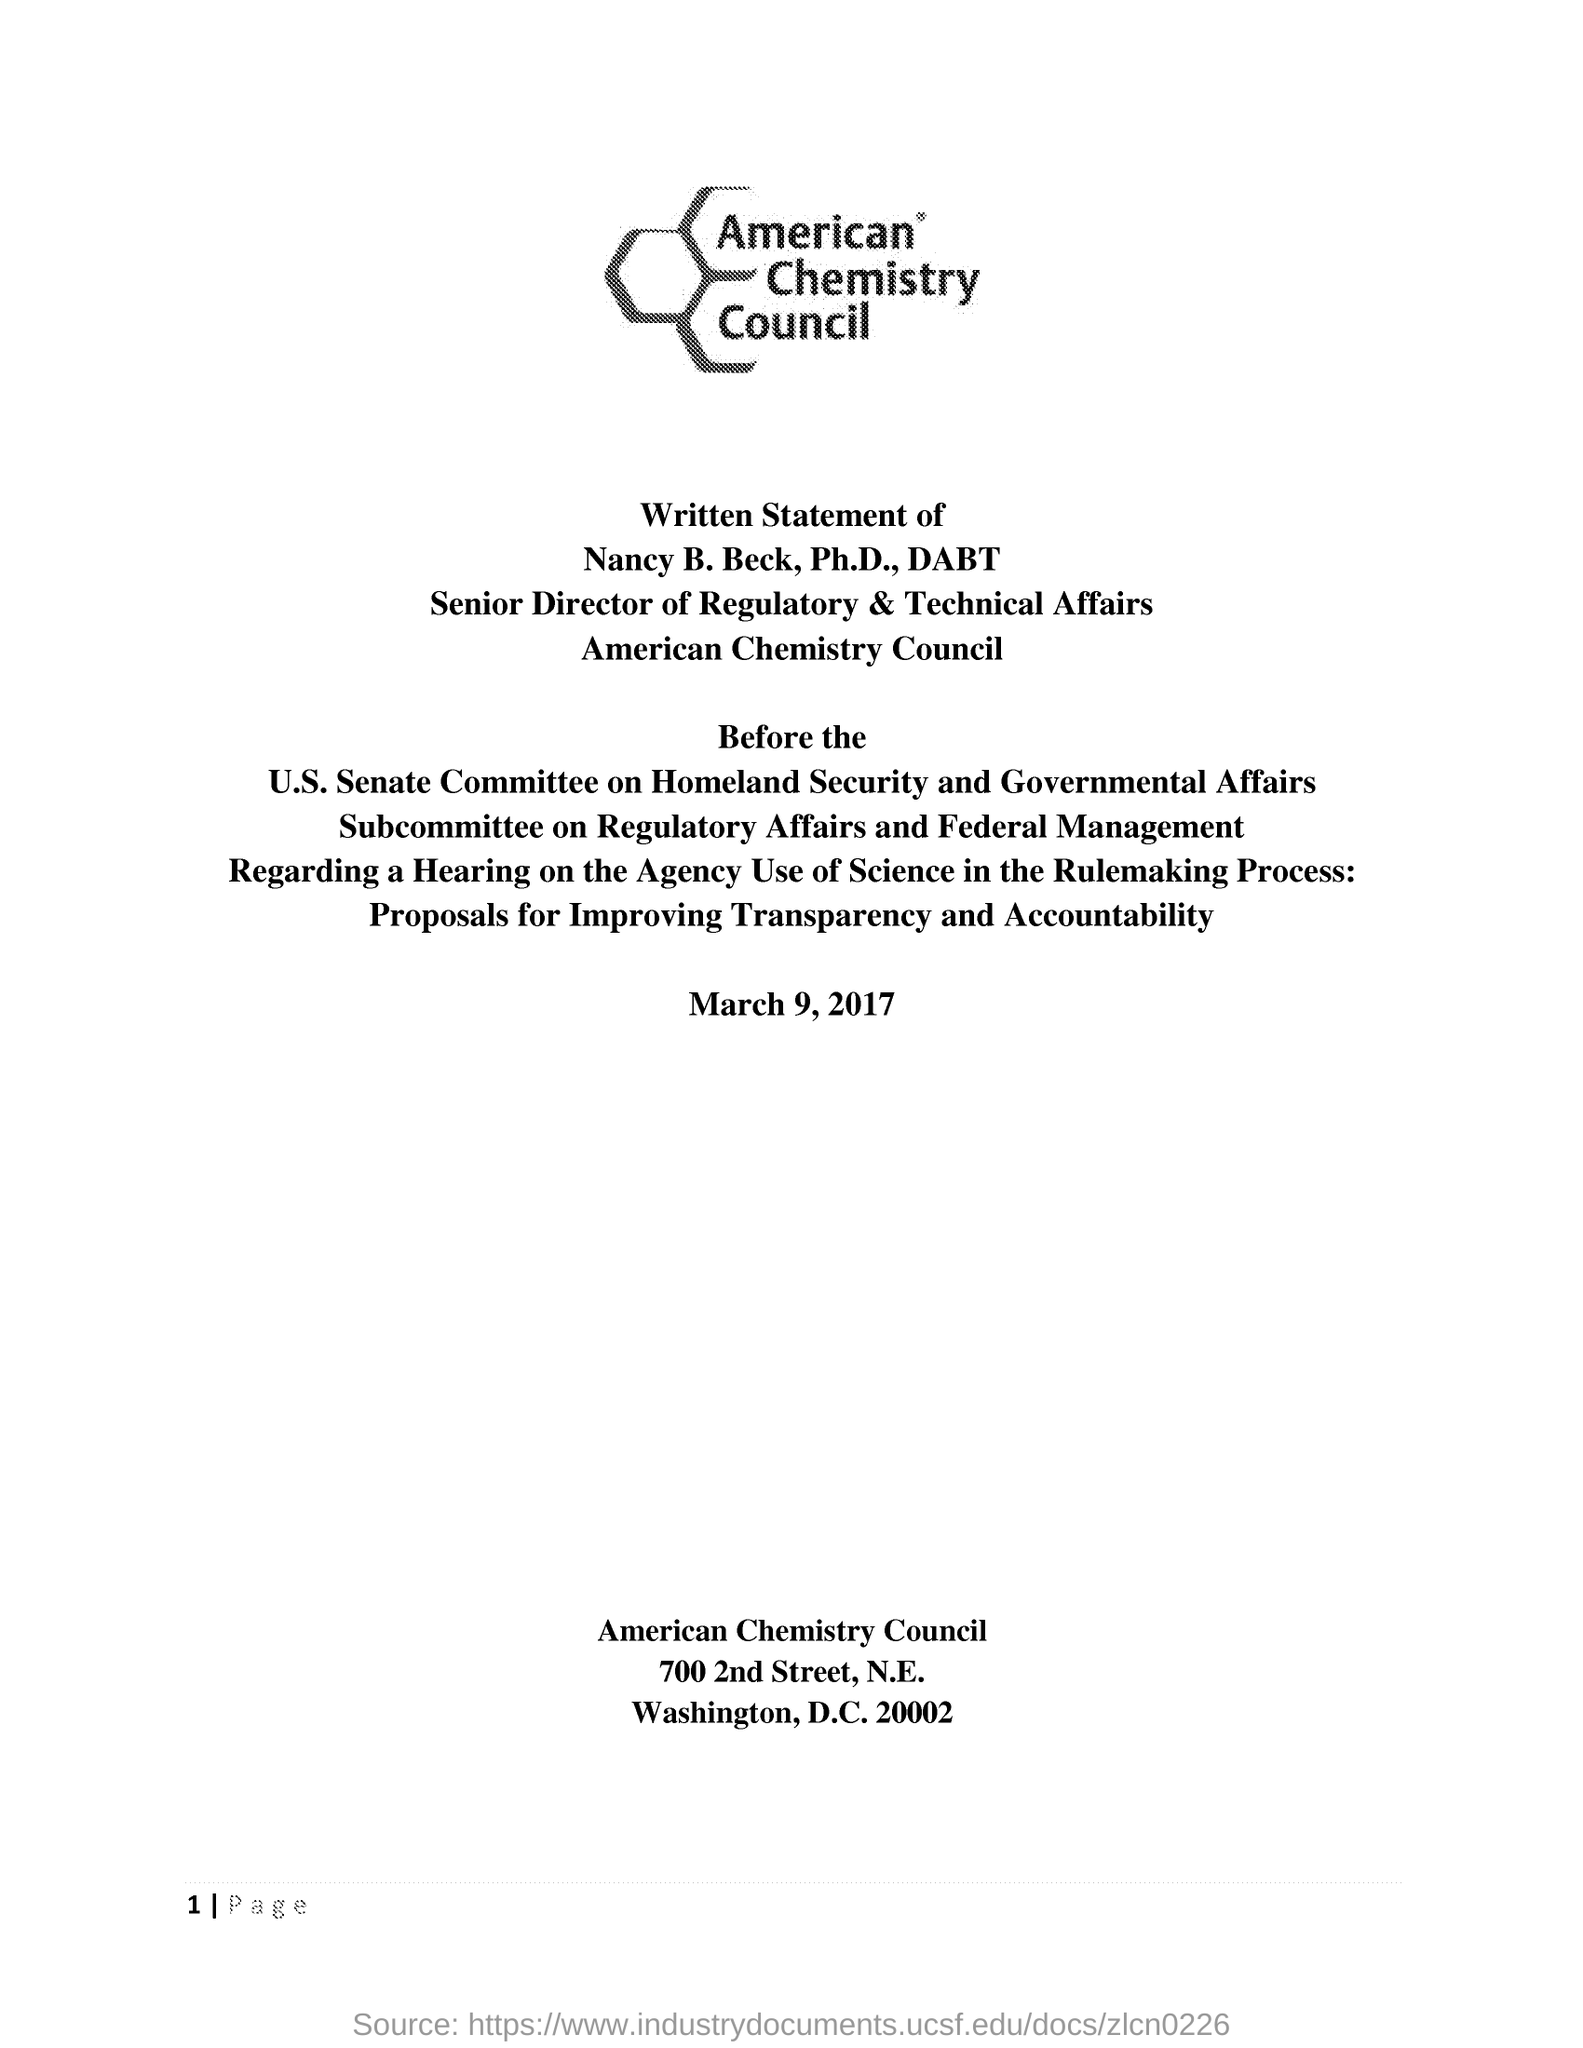Whose written statement does the document contain?
Your answer should be very brief. Nancy B. Beck, Ph.D., DABT. When is the Written Statement dated on?
Your answer should be compact. March 9, 2017. Which councils name is mentioned at the top?
Provide a short and direct response. American Chemistry Council. 